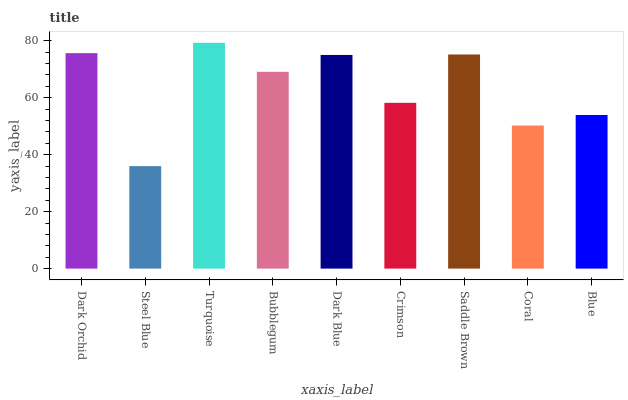Is Steel Blue the minimum?
Answer yes or no. Yes. Is Turquoise the maximum?
Answer yes or no. Yes. Is Turquoise the minimum?
Answer yes or no. No. Is Steel Blue the maximum?
Answer yes or no. No. Is Turquoise greater than Steel Blue?
Answer yes or no. Yes. Is Steel Blue less than Turquoise?
Answer yes or no. Yes. Is Steel Blue greater than Turquoise?
Answer yes or no. No. Is Turquoise less than Steel Blue?
Answer yes or no. No. Is Bubblegum the high median?
Answer yes or no. Yes. Is Bubblegum the low median?
Answer yes or no. Yes. Is Blue the high median?
Answer yes or no. No. Is Steel Blue the low median?
Answer yes or no. No. 